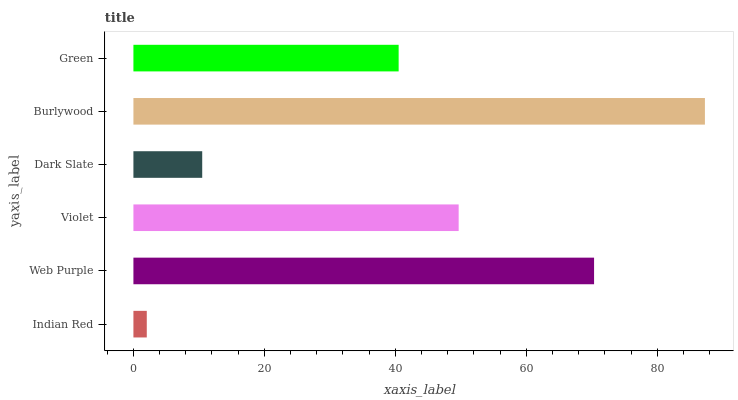Is Indian Red the minimum?
Answer yes or no. Yes. Is Burlywood the maximum?
Answer yes or no. Yes. Is Web Purple the minimum?
Answer yes or no. No. Is Web Purple the maximum?
Answer yes or no. No. Is Web Purple greater than Indian Red?
Answer yes or no. Yes. Is Indian Red less than Web Purple?
Answer yes or no. Yes. Is Indian Red greater than Web Purple?
Answer yes or no. No. Is Web Purple less than Indian Red?
Answer yes or no. No. Is Violet the high median?
Answer yes or no. Yes. Is Green the low median?
Answer yes or no. Yes. Is Web Purple the high median?
Answer yes or no. No. Is Dark Slate the low median?
Answer yes or no. No. 